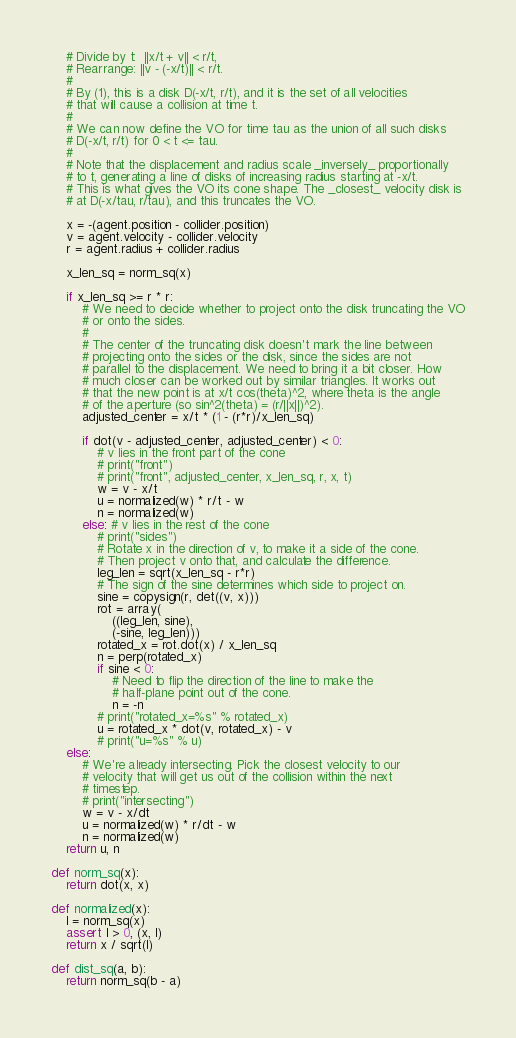Convert code to text. <code><loc_0><loc_0><loc_500><loc_500><_Python_>    # Divide by t:  ||x/t + v|| < r/t,
    # Rearrange: ||v - (-x/t)|| < r/t.
    #
    # By (1), this is a disk D(-x/t, r/t), and it is the set of all velocities
    # that will cause a collision at time t.
    #
    # We can now define the VO for time tau as the union of all such disks
    # D(-x/t, r/t) for 0 < t <= tau.
    #
    # Note that the displacement and radius scale _inversely_ proportionally
    # to t, generating a line of disks of increasing radius starting at -x/t.
    # This is what gives the VO its cone shape. The _closest_ velocity disk is
    # at D(-x/tau, r/tau), and this truncates the VO.

    x = -(agent.position - collider.position)
    v = agent.velocity - collider.velocity
    r = agent.radius + collider.radius

    x_len_sq = norm_sq(x)

    if x_len_sq >= r * r:
        # We need to decide whether to project onto the disk truncating the VO
        # or onto the sides.
        #
        # The center of the truncating disk doesn't mark the line between
        # projecting onto the sides or the disk, since the sides are not
        # parallel to the displacement. We need to bring it a bit closer. How
        # much closer can be worked out by similar triangles. It works out
        # that the new point is at x/t cos(theta)^2, where theta is the angle
        # of the aperture (so sin^2(theta) = (r/||x||)^2).
        adjusted_center = x/t * (1 - (r*r)/x_len_sq)

        if dot(v - adjusted_center, adjusted_center) < 0:
            # v lies in the front part of the cone
            # print("front")
            # print("front", adjusted_center, x_len_sq, r, x, t)
            w = v - x/t
            u = normalized(w) * r/t - w
            n = normalized(w)
        else: # v lies in the rest of the cone
            # print("sides")
            # Rotate x in the direction of v, to make it a side of the cone.
            # Then project v onto that, and calculate the difference.
            leg_len = sqrt(x_len_sq - r*r)
            # The sign of the sine determines which side to project on.
            sine = copysign(r, det((v, x)))
            rot = array(
                ((leg_len, sine),
                (-sine, leg_len)))
            rotated_x = rot.dot(x) / x_len_sq
            n = perp(rotated_x)
            if sine < 0:
                # Need to flip the direction of the line to make the
                # half-plane point out of the cone.
                n = -n
            # print("rotated_x=%s" % rotated_x)
            u = rotated_x * dot(v, rotated_x) - v
            # print("u=%s" % u)
    else:
        # We're already intersecting. Pick the closest velocity to our
        # velocity that will get us out of the collision within the next
        # timestep.
        # print("intersecting")
        w = v - x/dt
        u = normalized(w) * r/dt - w
        n = normalized(w)
    return u, n

def norm_sq(x):
    return dot(x, x)

def normalized(x):
    l = norm_sq(x)
    assert l > 0, (x, l)
    return x / sqrt(l)

def dist_sq(a, b):
    return norm_sq(b - a)
</code> 